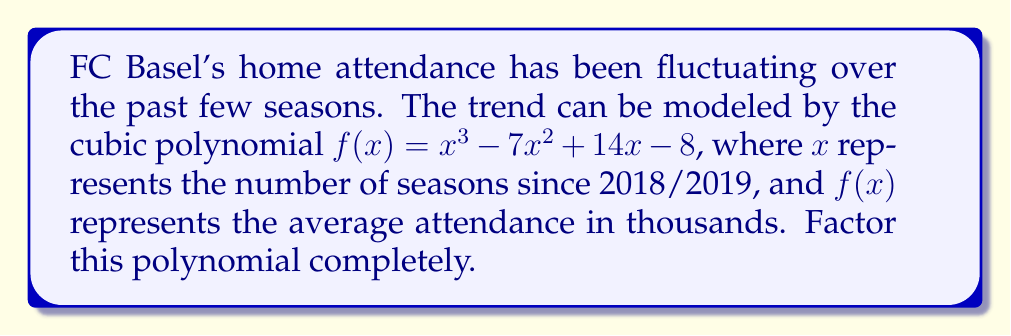Can you solve this math problem? Let's approach this step-by-step:

1) First, we need to check if there are any rational roots. We can use the rational root theorem. The possible rational roots are the factors of the constant term: ±1, ±2, ±4, ±8.

2) Testing these values, we find that $f(1) = 0$. So $(x-1)$ is a factor.

3) We can use polynomial long division to divide $f(x)$ by $(x-1)$:

   $$\frac{x^3 - 7x^2 + 14x - 8}{x-1} = x^2 - 6x + 8$$

4) So now we have: $f(x) = (x-1)(x^2 - 6x + 8)$

5) We need to factor the quadratic term $x^2 - 6x + 8$. We can use the quadratic formula or factoring by grouping.

6) The quadratic formula gives us:
   
   $$x = \frac{6 \pm \sqrt{36 - 32}}{2} = \frac{6 \pm 2}{2}$$

   So the roots are 4 and 2.

7) Therefore, $x^2 - 6x + 8 = (x-4)(x-2)$

8) Putting it all together, we get:

   $$f(x) = (x-1)(x-4)(x-2)$$

This factorization shows that FC Basel's attendance trend has three potential "zero points" or crossover seasons at 1, 2, and 4 years after the 2018/2019 season.
Answer: $f(x) = (x-1)(x-4)(x-2)$ 